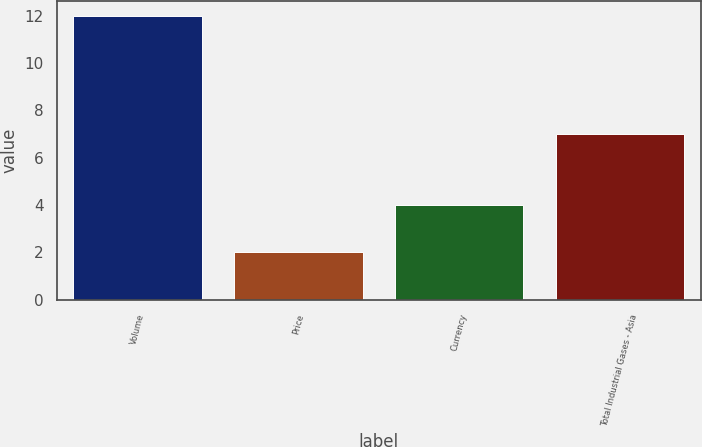Convert chart to OTSL. <chart><loc_0><loc_0><loc_500><loc_500><bar_chart><fcel>Volume<fcel>Price<fcel>Currency<fcel>Total Industrial Gases - Asia<nl><fcel>12<fcel>2<fcel>4<fcel>7<nl></chart> 